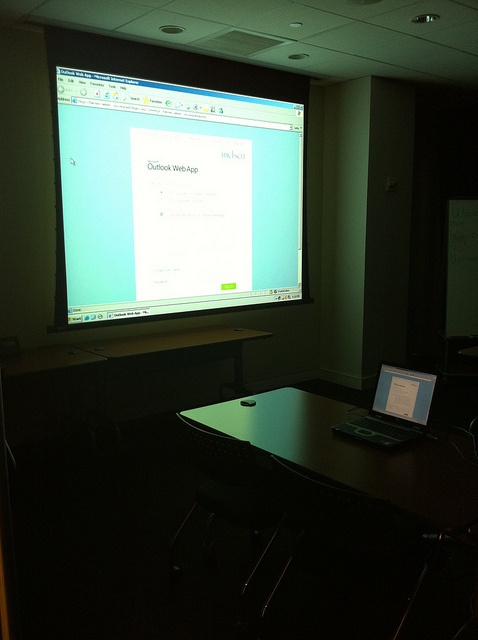Describe the objects in this image and their specific colors. I can see tv in black, ivory, and aquamarine tones, laptop in black, green, and teal tones, laptop in black, gray, and purple tones, tv in black, gray, and purple tones, and chair in black, maroon, darkgreen, and gray tones in this image. 